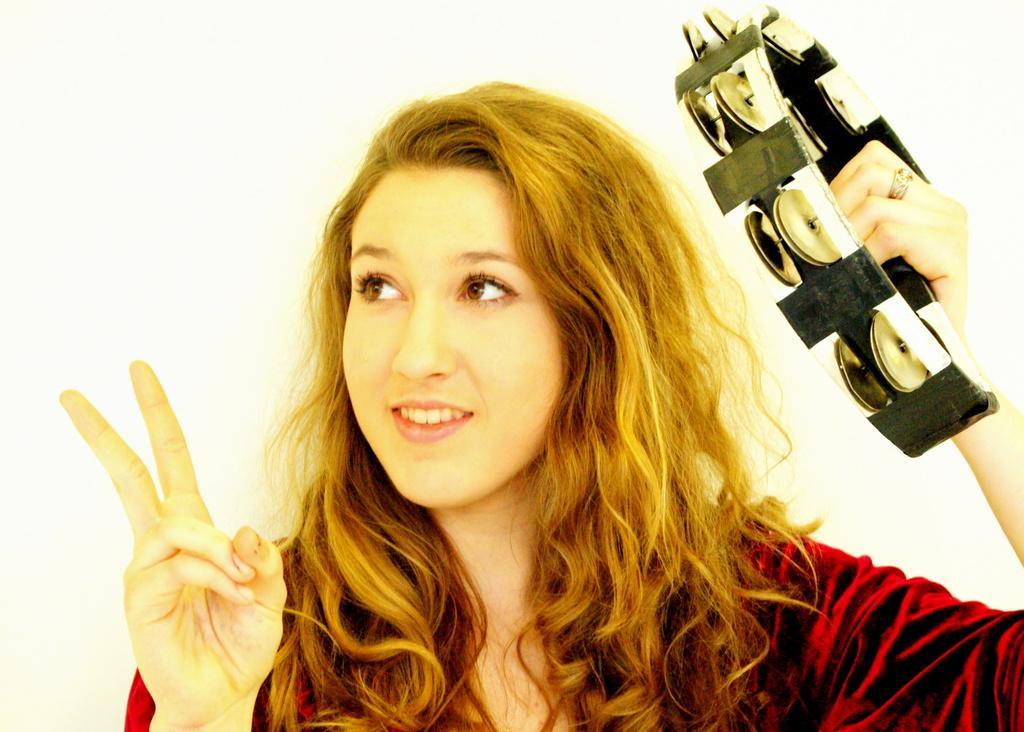In one or two sentences, can you explain what this image depicts? In this picture, we see a woman is wearing the maroon dress. She is holding the tambourine in her hand. She is smiling and she might be posing for the photo. In the background, it is white in color. 